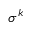Convert formula to latex. <formula><loc_0><loc_0><loc_500><loc_500>\sigma ^ { k }</formula> 